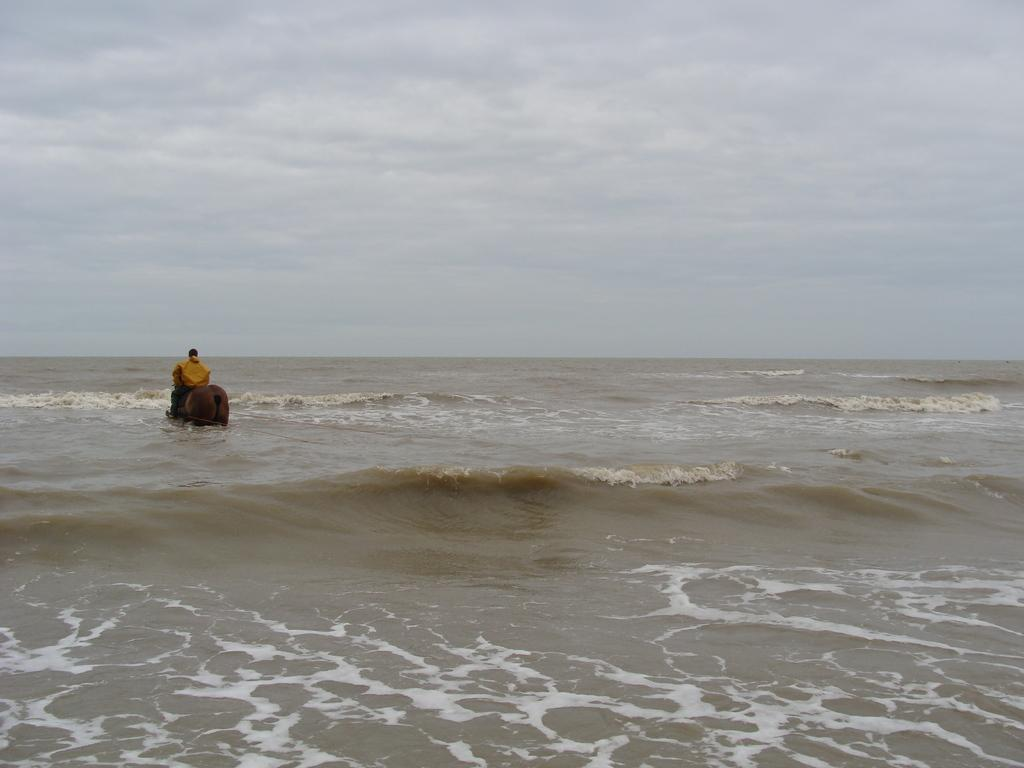What type of location is shown in the image? The image depicts a beach. Can you describe the person in the image? There is a person in the image. What is the person doing in the image? The person is on an animal. What type of lettuce is being used as a coat by the person in the image? There is no lettuce or coat present in the image. The person is on an animal, but there is no mention of lettuce or a coat being used. 